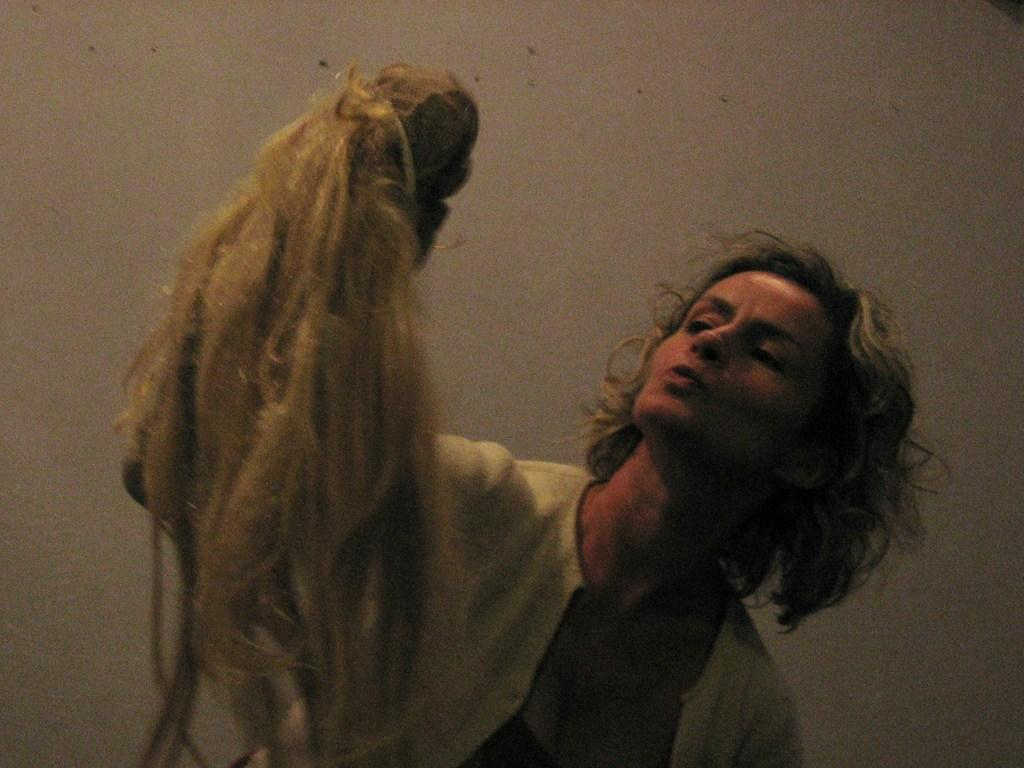Who is the main subject in the image? There is a woman in the image. What is the woman doing in the image? The woman is looking at a doll. How is the doll being held in the image? The doll is in the woman's hand. What can be observed about the doll's appearance? The doll has long hair. What is visible in the background of the image? There is a wall in the background of the image. How many cats are sitting under the faucet in the image? There are no cats or faucets present in the image. 